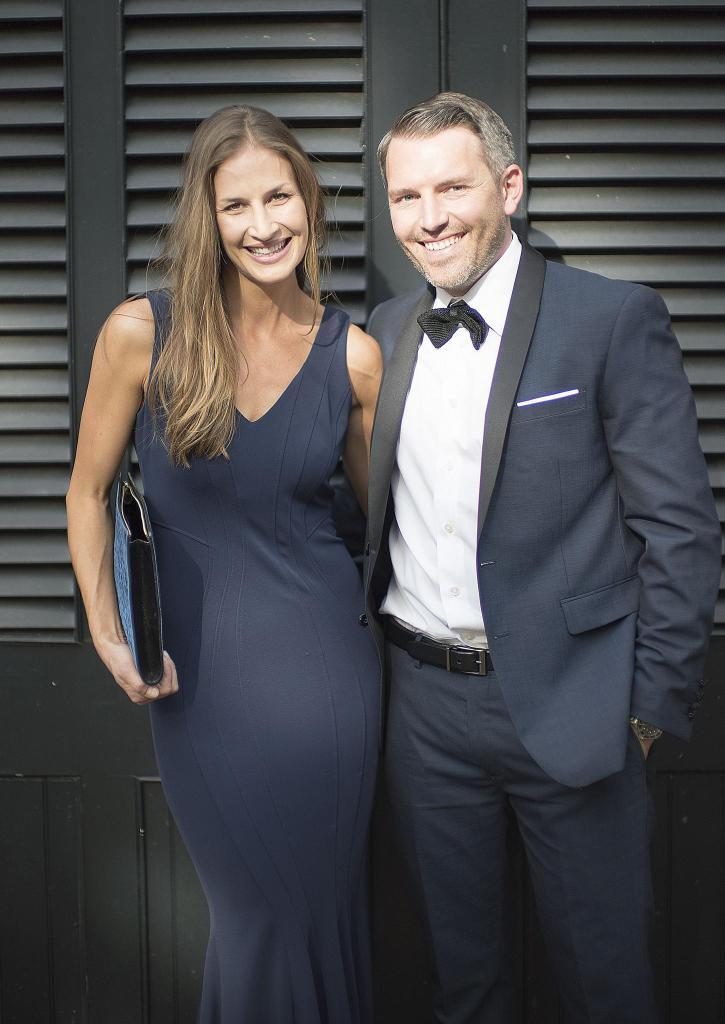Who are the people in the image? There is a woman and a man in the image. What is the woman holding in the image? The woman is holding a file. What can be seen in the background of the image? There is a door in the background of the image. What color is the crayon that the man is using in the image? There is no crayon present in the image, and the man is not using one. 